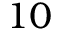<formula> <loc_0><loc_0><loc_500><loc_500>1 0</formula> 